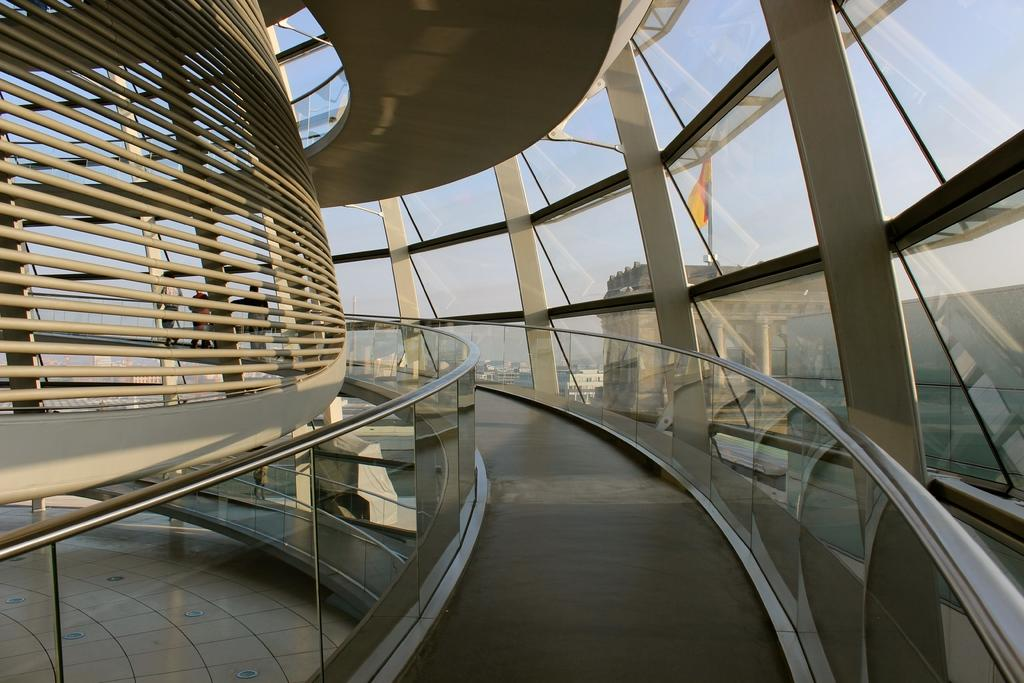What type of structure is present in the image? There is a building in the image. What feature is present in the building? The building has a way or path. What type of windows are present in the building? There are glass windows in the building. What can be seen in the background of the image? There are other buildings visible in the background. What is visible at the top of the image? The sky is visible at the top of the image. What type of bath can be seen in the image? There is no bath present in the image; it features a building with a way or path, glass windows, and other buildings in the background. How does the building relate to the other buildings in the image? The provided facts do not mention any specific relationship between the building and the other buildings in the image. 